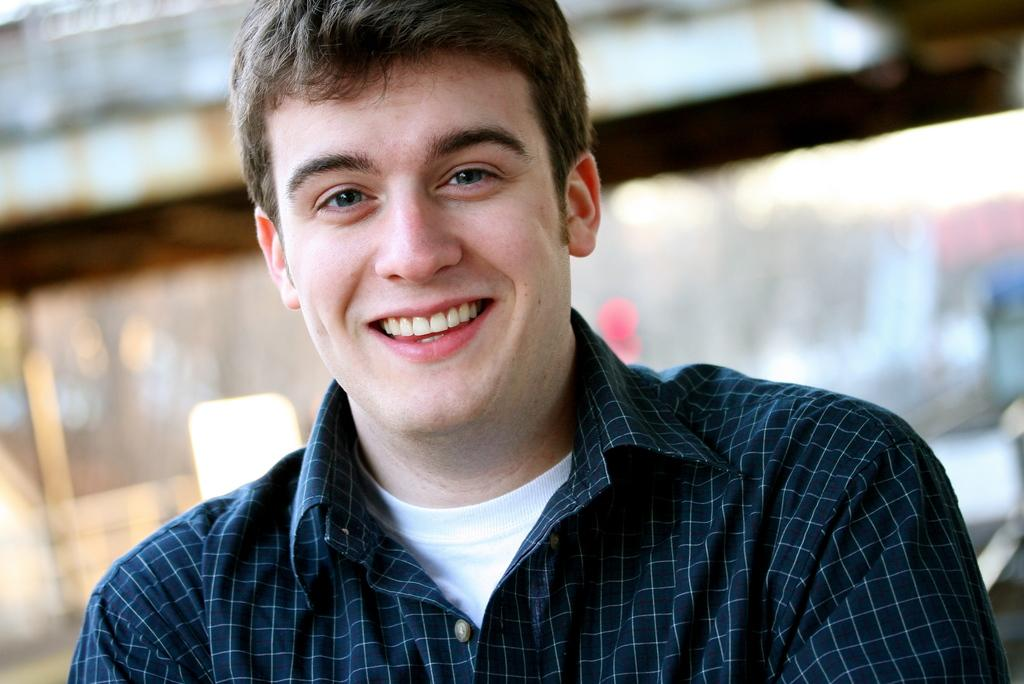Who or what is the main subject of the image? There is a person in the image. What is the person wearing? The person is wearing a checked shirt. What is the person's facial expression in the image? The person is smiling. Can you describe the background of the image? The background of the image is blurry. What type of berry can be seen in the person's hand in the image? There is no berry present in the person's hand or in the image. 